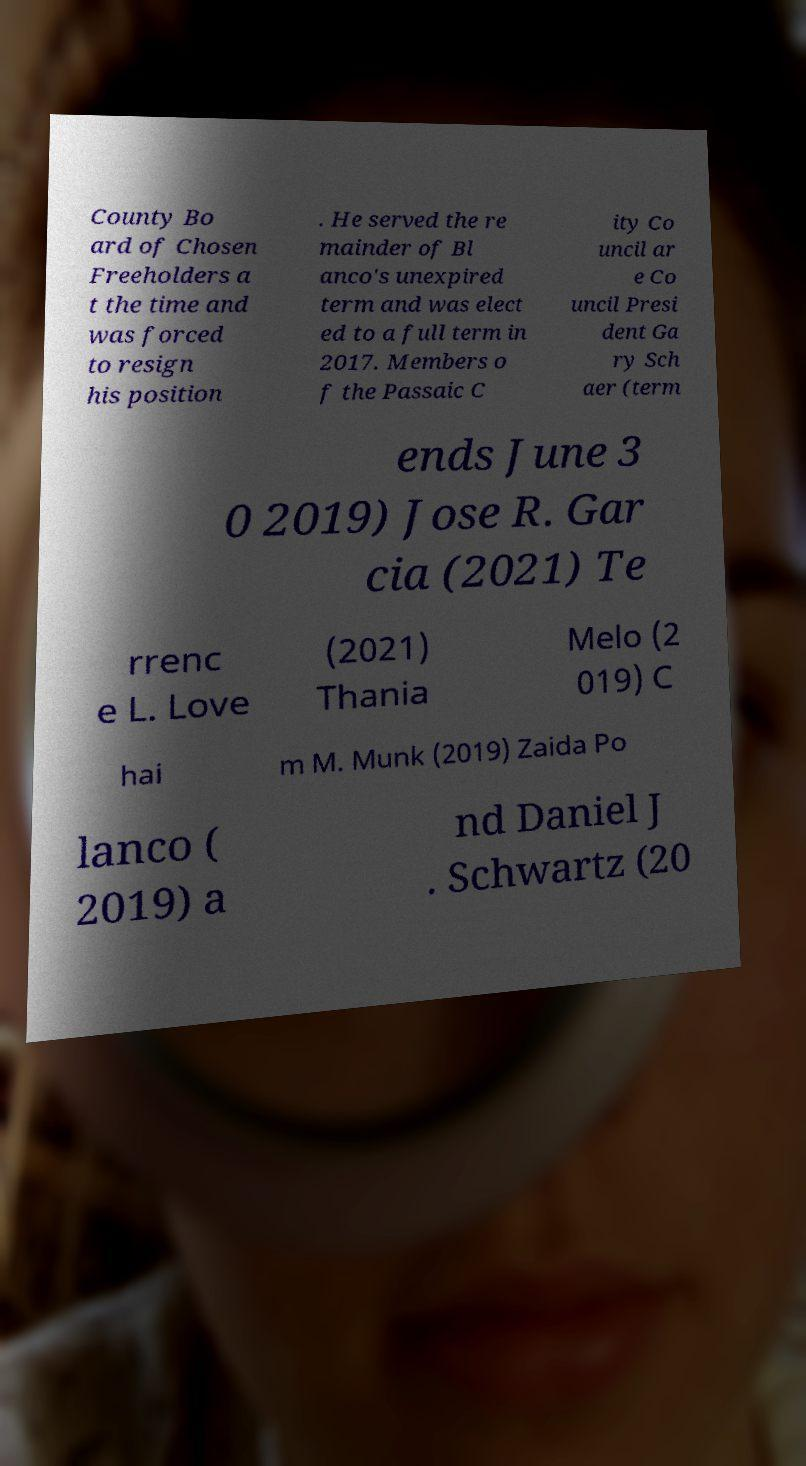Could you assist in decoding the text presented in this image and type it out clearly? County Bo ard of Chosen Freeholders a t the time and was forced to resign his position . He served the re mainder of Bl anco's unexpired term and was elect ed to a full term in 2017. Members o f the Passaic C ity Co uncil ar e Co uncil Presi dent Ga ry Sch aer (term ends June 3 0 2019) Jose R. Gar cia (2021) Te rrenc e L. Love (2021) Thania Melo (2 019) C hai m M. Munk (2019) Zaida Po lanco ( 2019) a nd Daniel J . Schwartz (20 